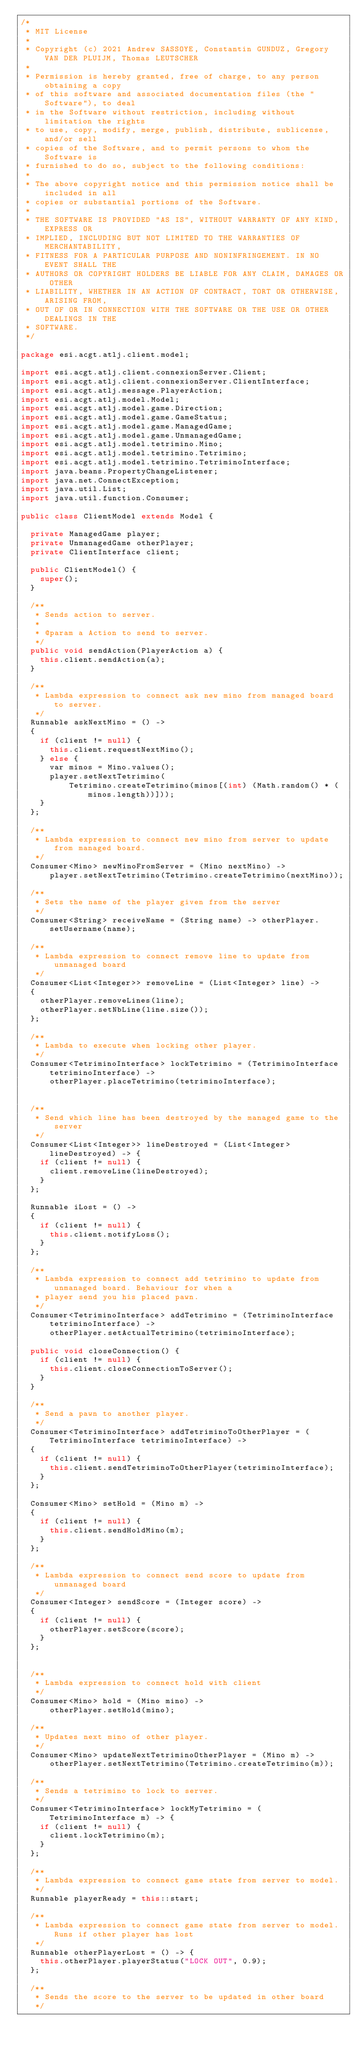Convert code to text. <code><loc_0><loc_0><loc_500><loc_500><_Java_>/*
 * MIT License
 *
 * Copyright (c) 2021 Andrew SASSOYE, Constantin GUNDUZ, Gregory VAN DER PLUIJM, Thomas LEUTSCHER
 *
 * Permission is hereby granted, free of charge, to any person obtaining a copy
 * of this software and associated documentation files (the "Software"), to deal
 * in the Software without restriction, including without limitation the rights
 * to use, copy, modify, merge, publish, distribute, sublicense, and/or sell
 * copies of the Software, and to permit persons to whom the Software is
 * furnished to do so, subject to the following conditions:
 *
 * The above copyright notice and this permission notice shall be included in all
 * copies or substantial portions of the Software.
 *
 * THE SOFTWARE IS PROVIDED "AS IS", WITHOUT WARRANTY OF ANY KIND, EXPRESS OR
 * IMPLIED, INCLUDING BUT NOT LIMITED TO THE WARRANTIES OF MERCHANTABILITY,
 * FITNESS FOR A PARTICULAR PURPOSE AND NONINFRINGEMENT. IN NO EVENT SHALL THE
 * AUTHORS OR COPYRIGHT HOLDERS BE LIABLE FOR ANY CLAIM, DAMAGES OR OTHER
 * LIABILITY, WHETHER IN AN ACTION OF CONTRACT, TORT OR OTHERWISE, ARISING FROM,
 * OUT OF OR IN CONNECTION WITH THE SOFTWARE OR THE USE OR OTHER DEALINGS IN THE
 * SOFTWARE.
 */

package esi.acgt.atlj.client.model;

import esi.acgt.atlj.client.connexionServer.Client;
import esi.acgt.atlj.client.connexionServer.ClientInterface;
import esi.acgt.atlj.message.PlayerAction;
import esi.acgt.atlj.model.Model;
import esi.acgt.atlj.model.game.Direction;
import esi.acgt.atlj.model.game.GameStatus;
import esi.acgt.atlj.model.game.ManagedGame;
import esi.acgt.atlj.model.game.UnmanagedGame;
import esi.acgt.atlj.model.tetrimino.Mino;
import esi.acgt.atlj.model.tetrimino.Tetrimino;
import esi.acgt.atlj.model.tetrimino.TetriminoInterface;
import java.beans.PropertyChangeListener;
import java.net.ConnectException;
import java.util.List;
import java.util.function.Consumer;

public class ClientModel extends Model {

  private ManagedGame player;
  private UnmanagedGame otherPlayer;
  private ClientInterface client;

  public ClientModel() {
    super();
  }

  /**
   * Sends action to server.
   *
   * @param a Action to send to server.
   */
  public void sendAction(PlayerAction a) {
    this.client.sendAction(a);
  }

  /**
   * Lambda expression to connect ask new mino from managed board to server.
   */
  Runnable askNextMino = () ->
  {
    if (client != null) {
      this.client.requestNextMino();
    } else {
      var minos = Mino.values();
      player.setNextTetrimino(
          Tetrimino.createTetrimino(minos[(int) (Math.random() * (minos.length))]));
    }
  };

  /**
   * Lambda expression to connect new mino from server to update from managed board.
   */
  Consumer<Mino> newMinoFromServer = (Mino nextMino) ->
      player.setNextTetrimino(Tetrimino.createTetrimino(nextMino));

  /**
   * Sets the name of the player given from the server
   */
  Consumer<String> receiveName = (String name) -> otherPlayer.setUsername(name);

  /**
   * Lambda expression to connect remove line to update from unmanaged board
   */
  Consumer<List<Integer>> removeLine = (List<Integer> line) ->
  {
    otherPlayer.removeLines(line);
    otherPlayer.setNbLine(line.size());
  };

  /**
   * Lambda to execute when locking other player.
   */
  Consumer<TetriminoInterface> lockTetrimino = (TetriminoInterface tetriminoInterface) ->
      otherPlayer.placeTetrimino(tetriminoInterface);


  /**
   * Send which line has been destroyed by the managed game to the server
   */
  Consumer<List<Integer>> lineDestroyed = (List<Integer> lineDestroyed) -> {
    if (client != null) {
      client.removeLine(lineDestroyed);
    }
  };

  Runnable iLost = () ->
  {
    if (client != null) {
      this.client.notifyLoss();
    }
  };

  /**
   * Lambda expression to connect add tetrimino to update from unmanaged board. Behaviour for when a
   * player send you his placed pawn.
   */
  Consumer<TetriminoInterface> addTetrimino = (TetriminoInterface tetriminoInterface) ->
      otherPlayer.setActualTetrimino(tetriminoInterface);

  public void closeConnection() {
    if (client != null) {
      this.client.closeConnectionToServer();
    }
  }

  /**
   * Send a pawn to another player.
   */
  Consumer<TetriminoInterface> addTetriminoToOtherPlayer = (TetriminoInterface tetriminoInterface) ->
  {
    if (client != null) {
      this.client.sendTetriminoToOtherPlayer(tetriminoInterface);
    }
  };

  Consumer<Mino> setHold = (Mino m) ->
  {
    if (client != null) {
      this.client.sendHoldMino(m);
    }
  };

  /**
   * Lambda expression to connect send score to update from unmanaged board
   */
  Consumer<Integer> sendScore = (Integer score) ->
  {
    if (client != null) {
      otherPlayer.setScore(score);
    }
  };


  /**
   * Lambda expression to connect hold with client
   */
  Consumer<Mino> hold = (Mino mino) ->
      otherPlayer.setHold(mino);

  /**
   * Updates next mino of other player.
   */
  Consumer<Mino> updateNextTetriminoOtherPlayer = (Mino m) ->
      otherPlayer.setNextTetrimino(Tetrimino.createTetrimino(m));

  /**
   * Sends a tetrimino to lock to server.
   */
  Consumer<TetriminoInterface> lockMyTetrimino = (TetriminoInterface m) -> {
    if (client != null) {
      client.lockTetrimino(m);
    }
  };

  /**
   * Lambda expression to connect game state from server to model.
   */
  Runnable playerReady = this::start;

  /**
   * Lambda expression to connect game state from server to model. Runs if other player has lost
   */
  Runnable otherPlayerLost = () -> {
    this.otherPlayer.playerStatus("LOCK OUT", 0.9);
  };

  /**
   * Sends the score to the server to be updated in other board
   */</code> 